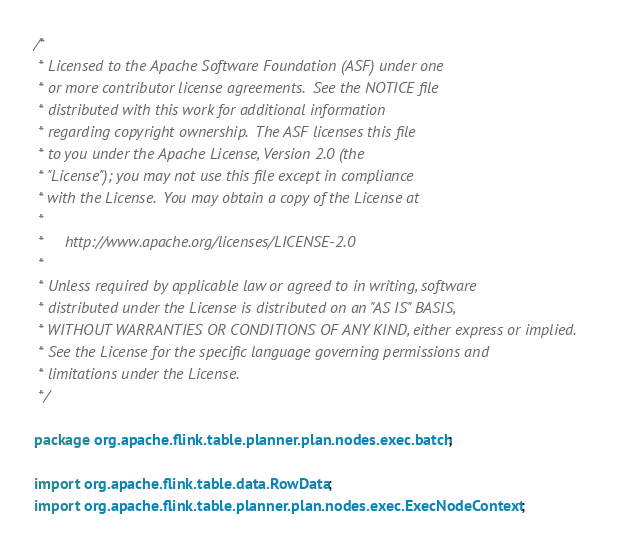Convert code to text. <code><loc_0><loc_0><loc_500><loc_500><_Java_>/*
 * Licensed to the Apache Software Foundation (ASF) under one
 * or more contributor license agreements.  See the NOTICE file
 * distributed with this work for additional information
 * regarding copyright ownership.  The ASF licenses this file
 * to you under the Apache License, Version 2.0 (the
 * "License"); you may not use this file except in compliance
 * with the License.  You may obtain a copy of the License at
 *
 *     http://www.apache.org/licenses/LICENSE-2.0
 *
 * Unless required by applicable law or agreed to in writing, software
 * distributed under the License is distributed on an "AS IS" BASIS,
 * WITHOUT WARRANTIES OR CONDITIONS OF ANY KIND, either express or implied.
 * See the License for the specific language governing permissions and
 * limitations under the License.
 */

package org.apache.flink.table.planner.plan.nodes.exec.batch;

import org.apache.flink.table.data.RowData;
import org.apache.flink.table.planner.plan.nodes.exec.ExecNodeContext;</code> 